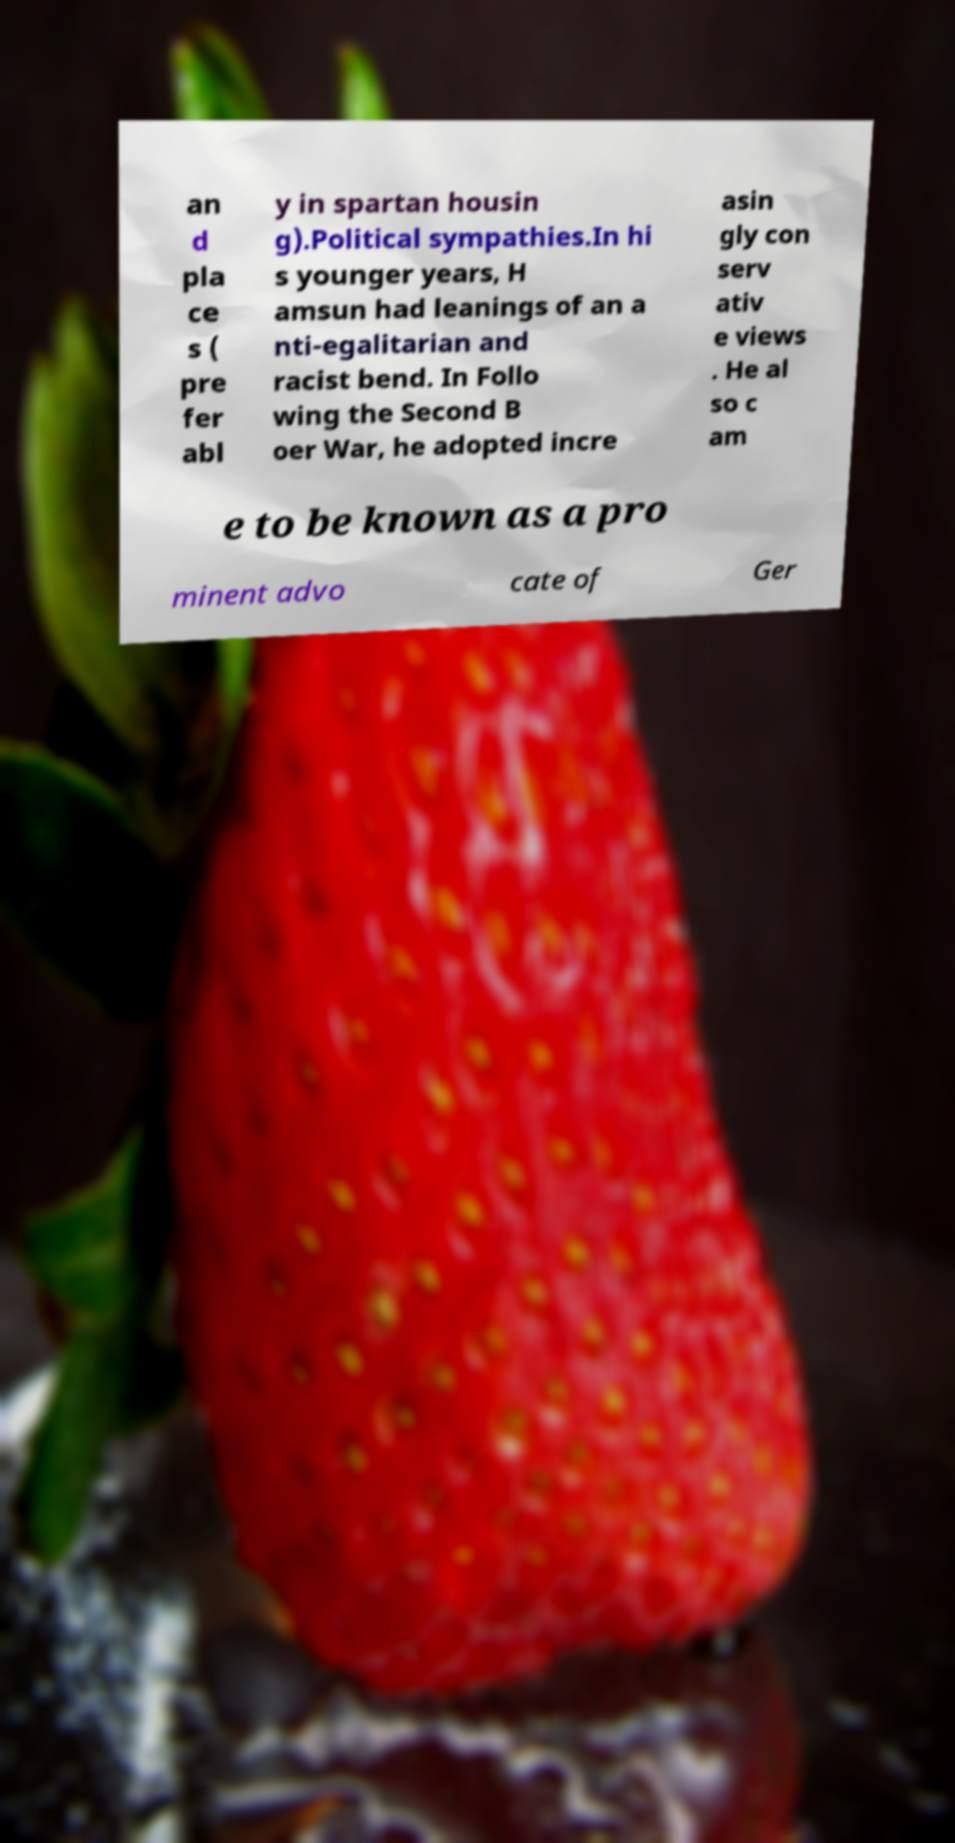Please identify and transcribe the text found in this image. an d pla ce s ( pre fer abl y in spartan housin g).Political sympathies.In hi s younger years, H amsun had leanings of an a nti-egalitarian and racist bend. In Follo wing the Second B oer War, he adopted incre asin gly con serv ativ e views . He al so c am e to be known as a pro minent advo cate of Ger 